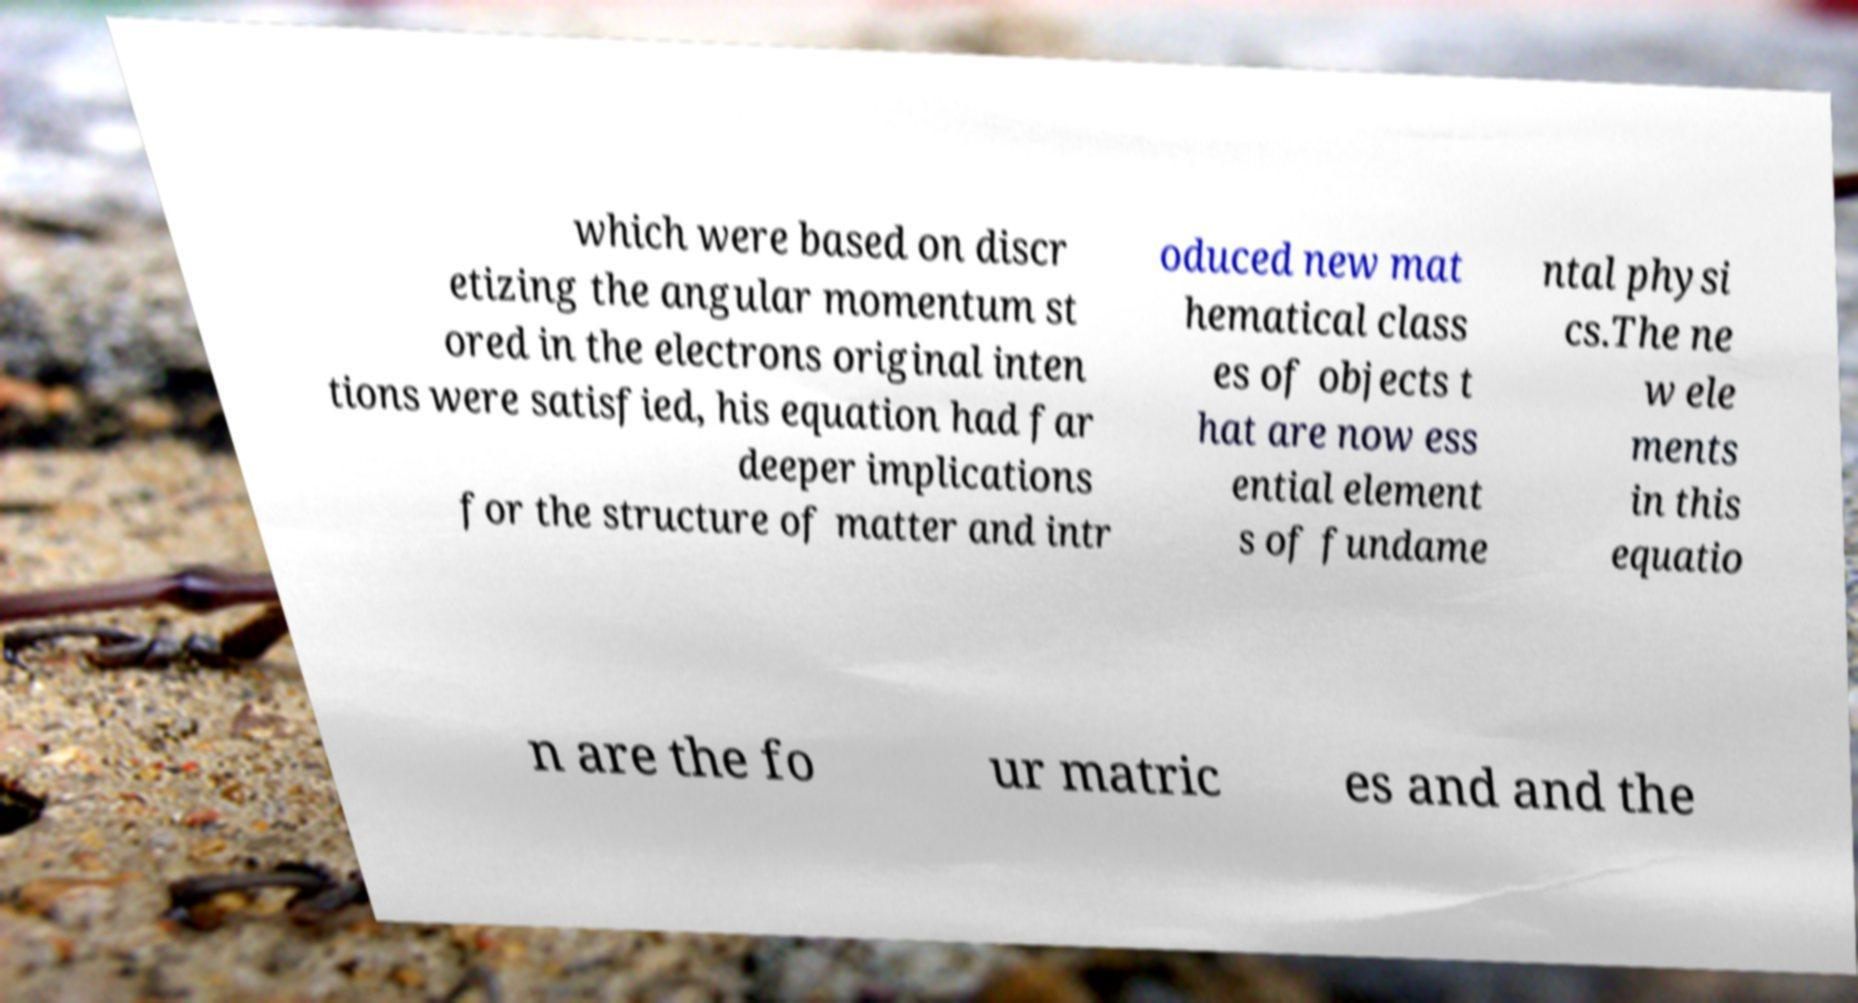Please identify and transcribe the text found in this image. which were based on discr etizing the angular momentum st ored in the electrons original inten tions were satisfied, his equation had far deeper implications for the structure of matter and intr oduced new mat hematical class es of objects t hat are now ess ential element s of fundame ntal physi cs.The ne w ele ments in this equatio n are the fo ur matric es and and the 